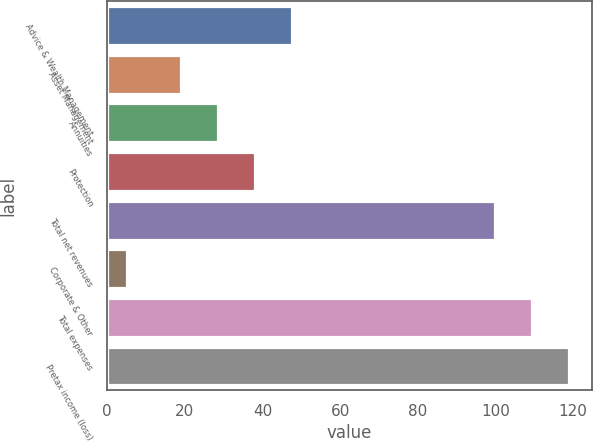<chart> <loc_0><loc_0><loc_500><loc_500><bar_chart><fcel>Advice & Wealth Management<fcel>Asset Management<fcel>Annuities<fcel>Protection<fcel>Total net revenues<fcel>Corporate & Other<fcel>Total expenses<fcel>Pretax income (loss)<nl><fcel>47.5<fcel>19<fcel>28.5<fcel>38<fcel>100<fcel>5<fcel>109.5<fcel>119<nl></chart> 